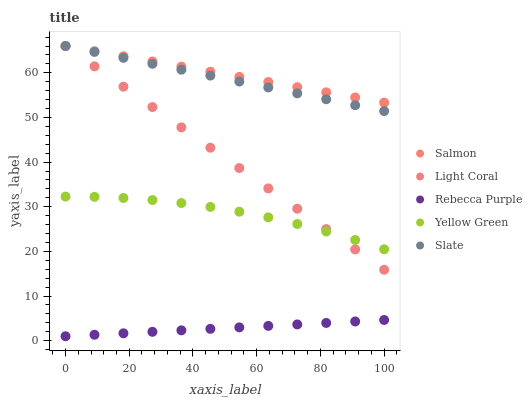Does Rebecca Purple have the minimum area under the curve?
Answer yes or no. Yes. Does Salmon have the maximum area under the curve?
Answer yes or no. Yes. Does Slate have the minimum area under the curve?
Answer yes or no. No. Does Slate have the maximum area under the curve?
Answer yes or no. No. Is Rebecca Purple the smoothest?
Answer yes or no. Yes. Is Yellow Green the roughest?
Answer yes or no. Yes. Is Slate the smoothest?
Answer yes or no. No. Is Slate the roughest?
Answer yes or no. No. Does Rebecca Purple have the lowest value?
Answer yes or no. Yes. Does Slate have the lowest value?
Answer yes or no. No. Does Salmon have the highest value?
Answer yes or no. Yes. Does Rebecca Purple have the highest value?
Answer yes or no. No. Is Yellow Green less than Salmon?
Answer yes or no. Yes. Is Light Coral greater than Rebecca Purple?
Answer yes or no. Yes. Does Salmon intersect Light Coral?
Answer yes or no. Yes. Is Salmon less than Light Coral?
Answer yes or no. No. Is Salmon greater than Light Coral?
Answer yes or no. No. Does Yellow Green intersect Salmon?
Answer yes or no. No. 